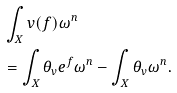Convert formula to latex. <formula><loc_0><loc_0><loc_500><loc_500>& \int _ { X } v ( f ) \omega ^ { n } \\ & = \int _ { X } \theta _ { v } e ^ { f } \omega ^ { n } - \int _ { X } \theta _ { v } \omega ^ { n } .</formula> 